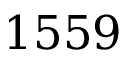<formula> <loc_0><loc_0><loc_500><loc_500>1 5 5 9</formula> 